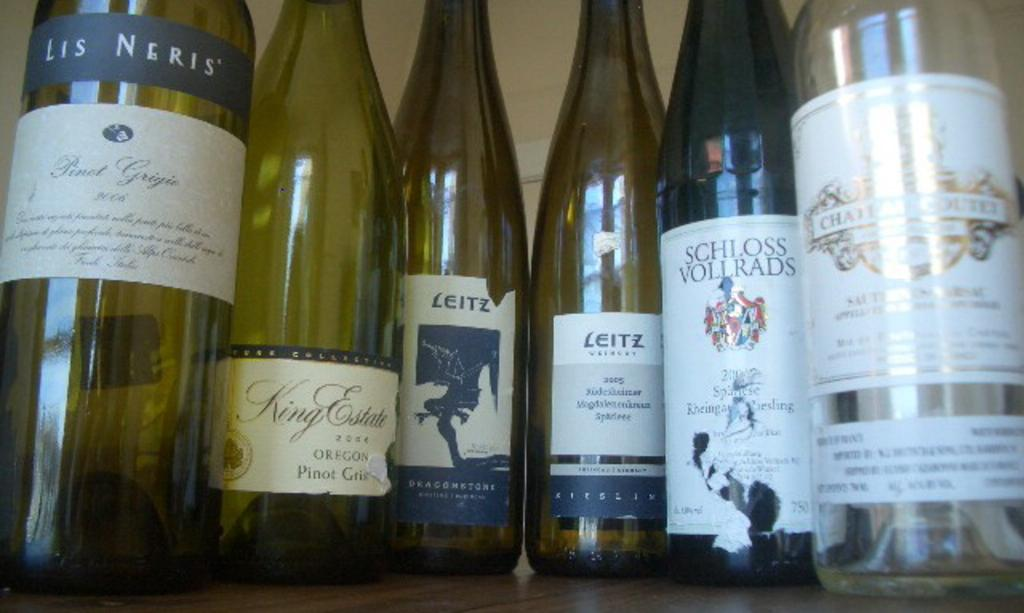<image>
Summarize the visual content of the image. One bottle of Les Neris wine, one bottle of King Estates, two bottles of Leitz, one bottle of Schloss Vollrads and one additional bottle of wine are pictured. 